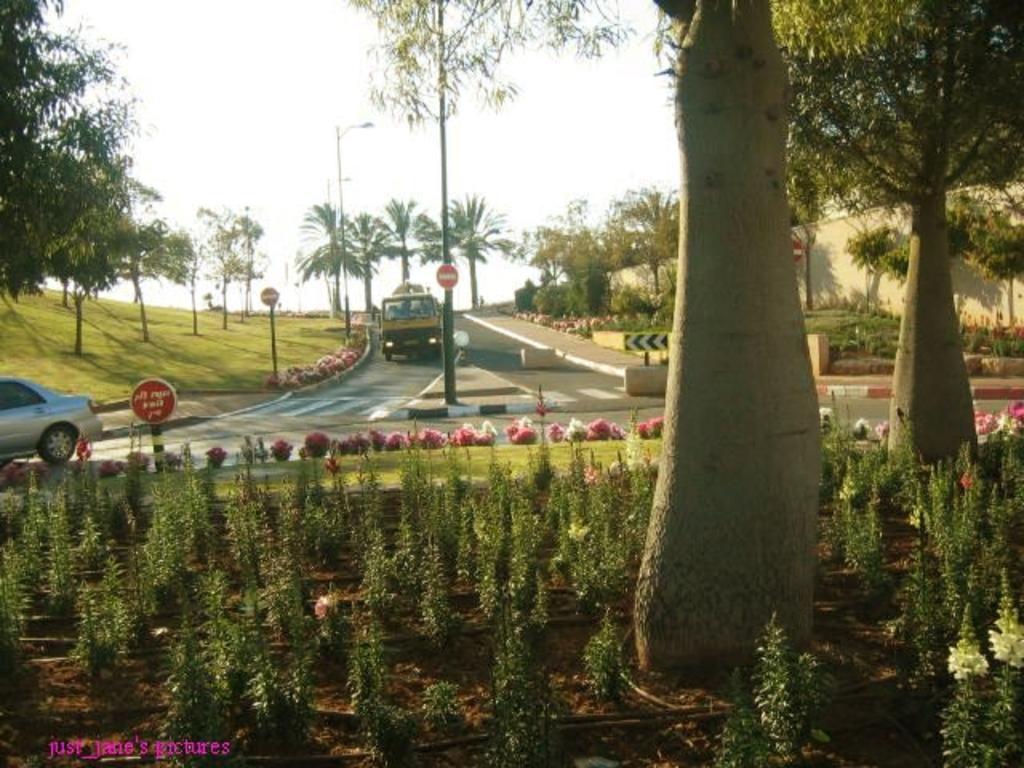Please provide a concise description of this image. In this picture we can see plants on the ground, grass, trees, poles, signboards, vehicles on the road, wall and in the background we can see the sky. 